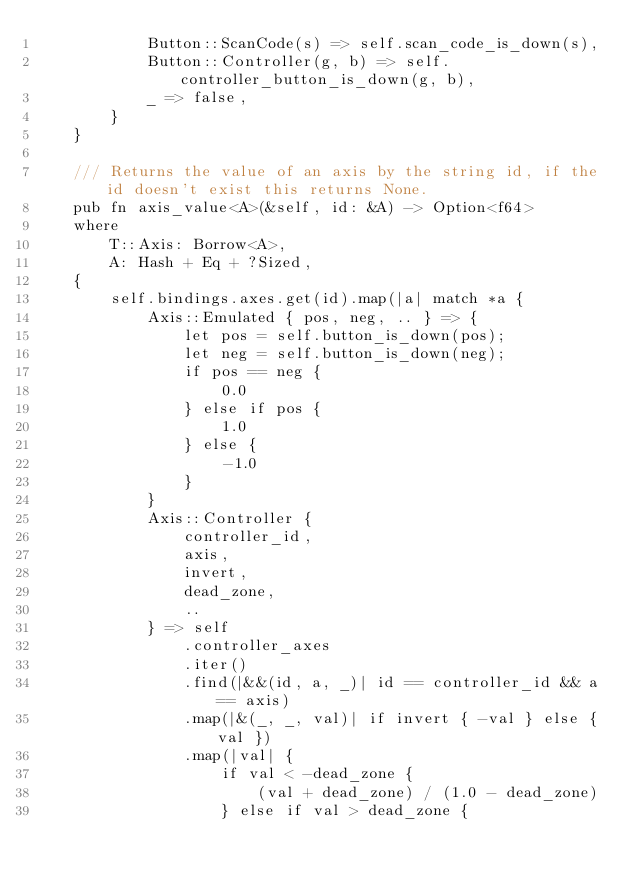<code> <loc_0><loc_0><loc_500><loc_500><_Rust_>            Button::ScanCode(s) => self.scan_code_is_down(s),
            Button::Controller(g, b) => self.controller_button_is_down(g, b),
            _ => false,
        }
    }

    /// Returns the value of an axis by the string id, if the id doesn't exist this returns None.
    pub fn axis_value<A>(&self, id: &A) -> Option<f64>
    where
        T::Axis: Borrow<A>,
        A: Hash + Eq + ?Sized,
    {
        self.bindings.axes.get(id).map(|a| match *a {
            Axis::Emulated { pos, neg, .. } => {
                let pos = self.button_is_down(pos);
                let neg = self.button_is_down(neg);
                if pos == neg {
                    0.0
                } else if pos {
                    1.0
                } else {
                    -1.0
                }
            }
            Axis::Controller {
                controller_id,
                axis,
                invert,
                dead_zone,
                ..
            } => self
                .controller_axes
                .iter()
                .find(|&&(id, a, _)| id == controller_id && a == axis)
                .map(|&(_, _, val)| if invert { -val } else { val })
                .map(|val| {
                    if val < -dead_zone {
                        (val + dead_zone) / (1.0 - dead_zone)
                    } else if val > dead_zone {</code> 